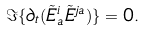Convert formula to latex. <formula><loc_0><loc_0><loc_500><loc_500>\Im \{ \partial _ { t } ( \tilde { E } ^ { i } _ { a } \tilde { E } ^ { j a } ) \} = 0 .</formula> 